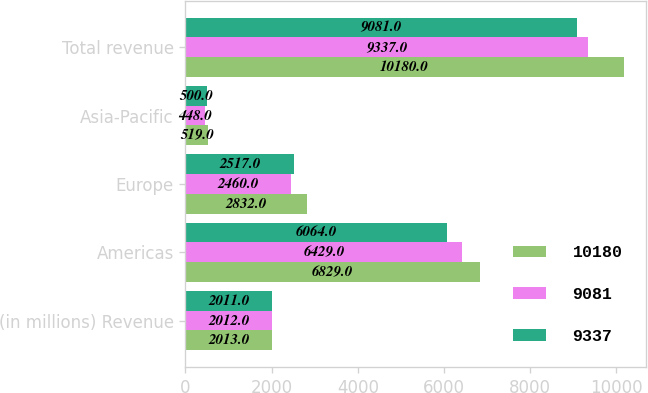Convert chart. <chart><loc_0><loc_0><loc_500><loc_500><stacked_bar_chart><ecel><fcel>(in millions) Revenue<fcel>Americas<fcel>Europe<fcel>Asia-Pacific<fcel>Total revenue<nl><fcel>10180<fcel>2013<fcel>6829<fcel>2832<fcel>519<fcel>10180<nl><fcel>9081<fcel>2012<fcel>6429<fcel>2460<fcel>448<fcel>9337<nl><fcel>9337<fcel>2011<fcel>6064<fcel>2517<fcel>500<fcel>9081<nl></chart> 